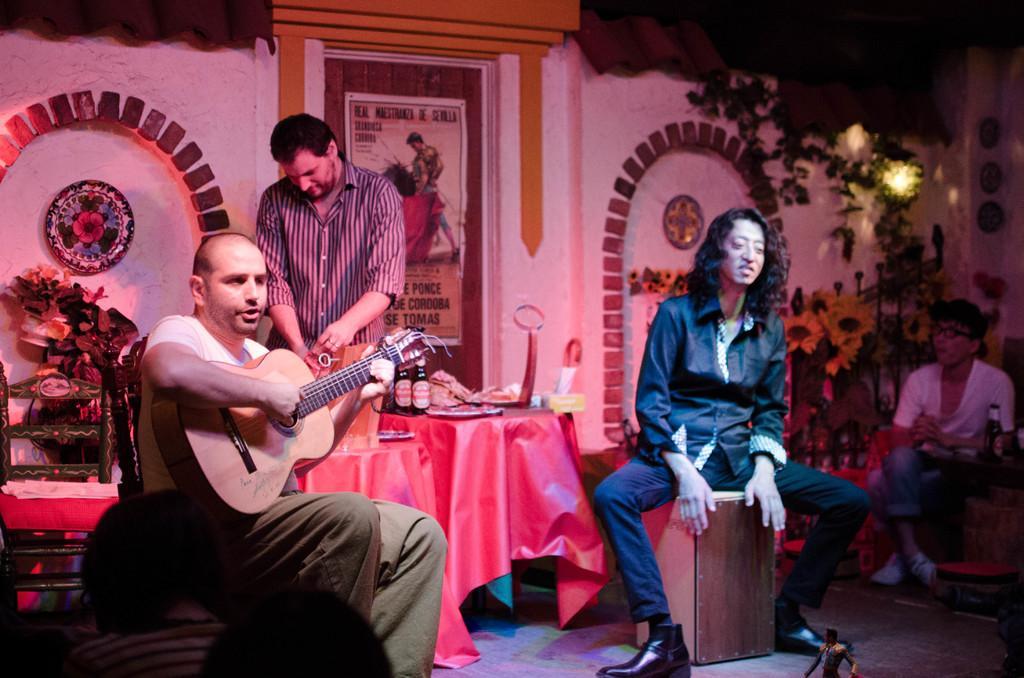Could you give a brief overview of what you see in this image? In this picture there is a man sitting holding a guitar with his left hand and playing the guitar with his right hand and there is a person standing behind him is holding an object, there is a table beside them with some beer bottles, food, tissues and stuff and there is another person sitting on a wooden box here is speaking and as a person sitting over here with a beer bottle and in the back of this was a poster and there are some plants and land 